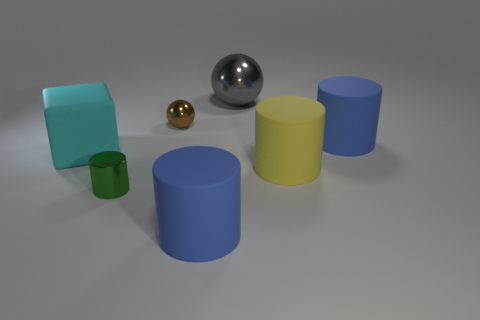There is a cylinder that is to the left of the sphere in front of the ball behind the tiny brown thing; what is its size?
Offer a terse response. Small. Does the metallic cylinder have the same size as the brown object?
Keep it short and to the point. Yes. Does the big blue matte thing behind the big cube have the same shape as the small object behind the metal cylinder?
Provide a succinct answer. No. There is a large thing right of the big yellow cylinder; are there any metallic things that are behind it?
Ensure brevity in your answer.  Yes. Are there any brown shiny spheres?
Ensure brevity in your answer.  Yes. How many other things have the same size as the gray object?
Make the answer very short. 4. What number of cylinders are to the right of the tiny cylinder and on the left side of the tiny sphere?
Keep it short and to the point. 0. There is a metal sphere on the right side of the brown thing; is it the same size as the block?
Offer a terse response. Yes. The gray thing that is the same material as the green cylinder is what size?
Your answer should be very brief. Large. Is the number of big matte objects right of the small cylinder greater than the number of small spheres that are in front of the big cube?
Keep it short and to the point. Yes. 